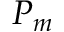Convert formula to latex. <formula><loc_0><loc_0><loc_500><loc_500>P _ { m }</formula> 